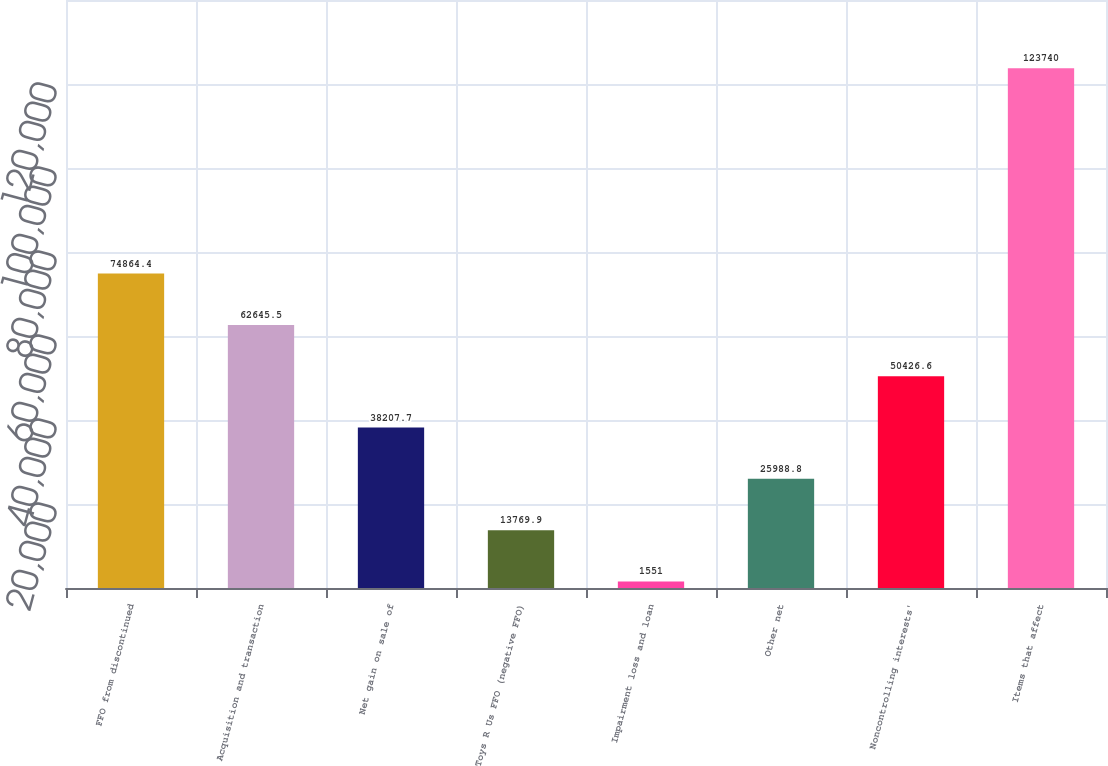<chart> <loc_0><loc_0><loc_500><loc_500><bar_chart><fcel>FFO from discontinued<fcel>Acquisition and transaction<fcel>Net gain on sale of<fcel>Toys R Us FFO (negative FFO)<fcel>Impairment loss and loan<fcel>Other net<fcel>Noncontrolling interests'<fcel>Items that affect<nl><fcel>74864.4<fcel>62645.5<fcel>38207.7<fcel>13769.9<fcel>1551<fcel>25988.8<fcel>50426.6<fcel>123740<nl></chart> 